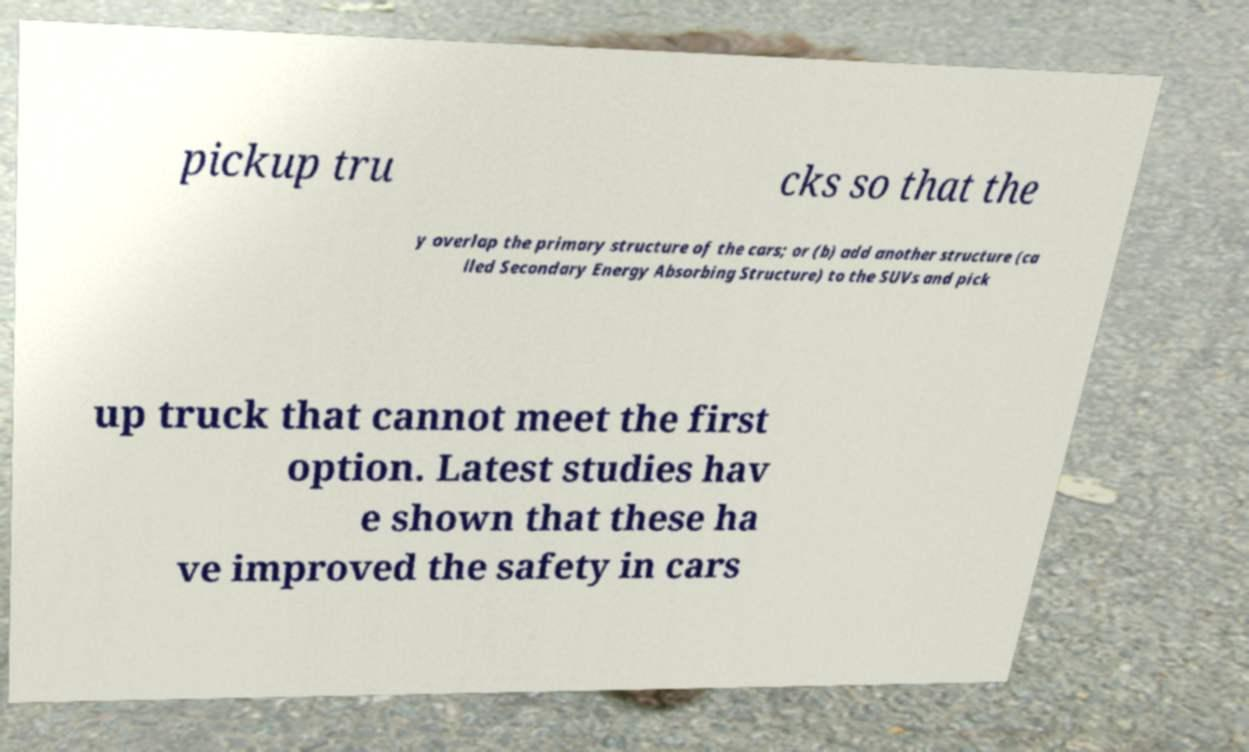Can you read and provide the text displayed in the image?This photo seems to have some interesting text. Can you extract and type it out for me? pickup tru cks so that the y overlap the primary structure of the cars; or (b) add another structure (ca lled Secondary Energy Absorbing Structure) to the SUVs and pick up truck that cannot meet the first option. Latest studies hav e shown that these ha ve improved the safety in cars 